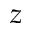<formula> <loc_0><loc_0><loc_500><loc_500>z</formula> 